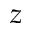<formula> <loc_0><loc_0><loc_500><loc_500>z</formula> 